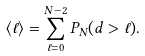Convert formula to latex. <formula><loc_0><loc_0><loc_500><loc_500>\langle \ell \rangle = \sum _ { \ell = 0 } ^ { N - 2 } P _ { N } ( d > \ell ) .</formula> 